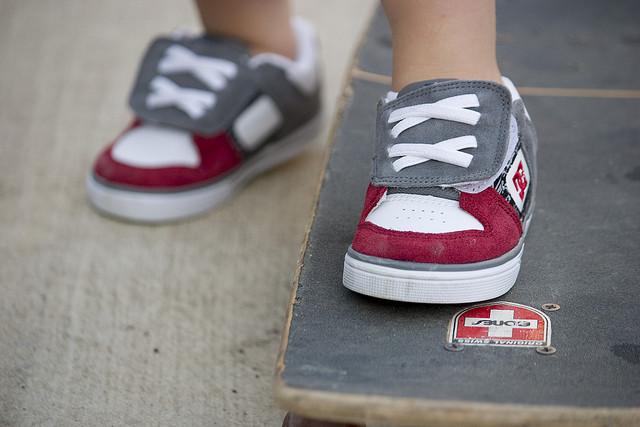What is in the shoe?
Be succinct. Foot. Are these traditional lace up sneakers?
Concise answer only. No. What is inside the shoe?
Short answer required. Foot. How many feet are in focus?
Concise answer only. 1. What brand is the shoes?
Be succinct. Dc. Is one foot on a skateboard?
Short answer required. Yes. What size shoe are they?
Write a very short answer. 1. 